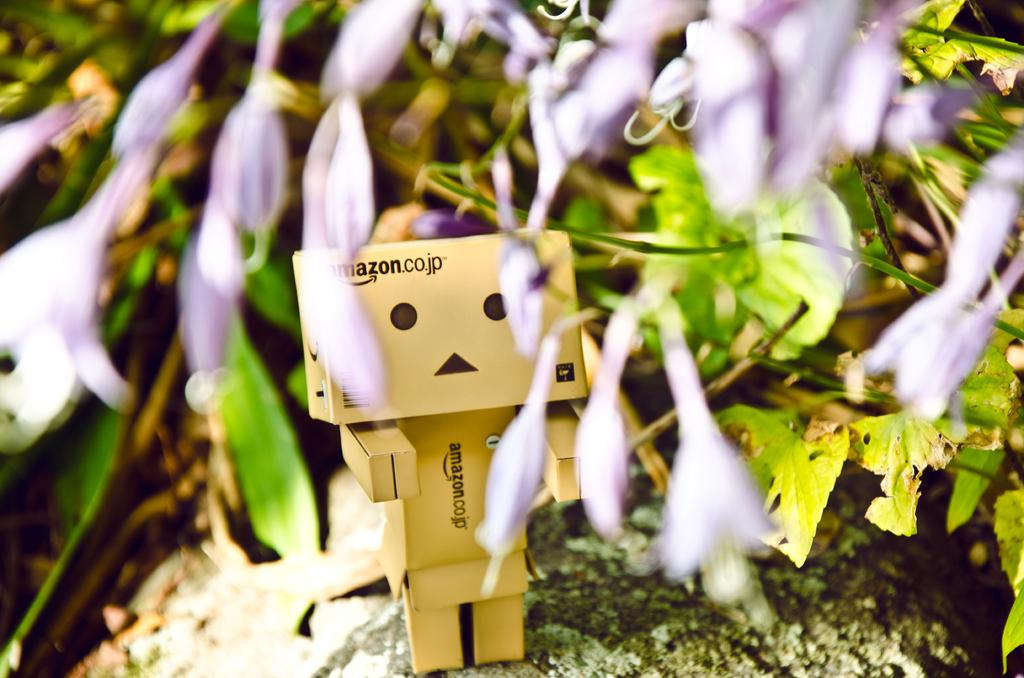What type of plants can be seen in the image? There are flowers and leaves in the image. Can you describe the object on the ground in the image? Unfortunately, the facts provided do not give enough information to describe the object on the ground. Is the father playing baseball with his child in the image? There is no reference to a father or a child playing baseball in the image. 